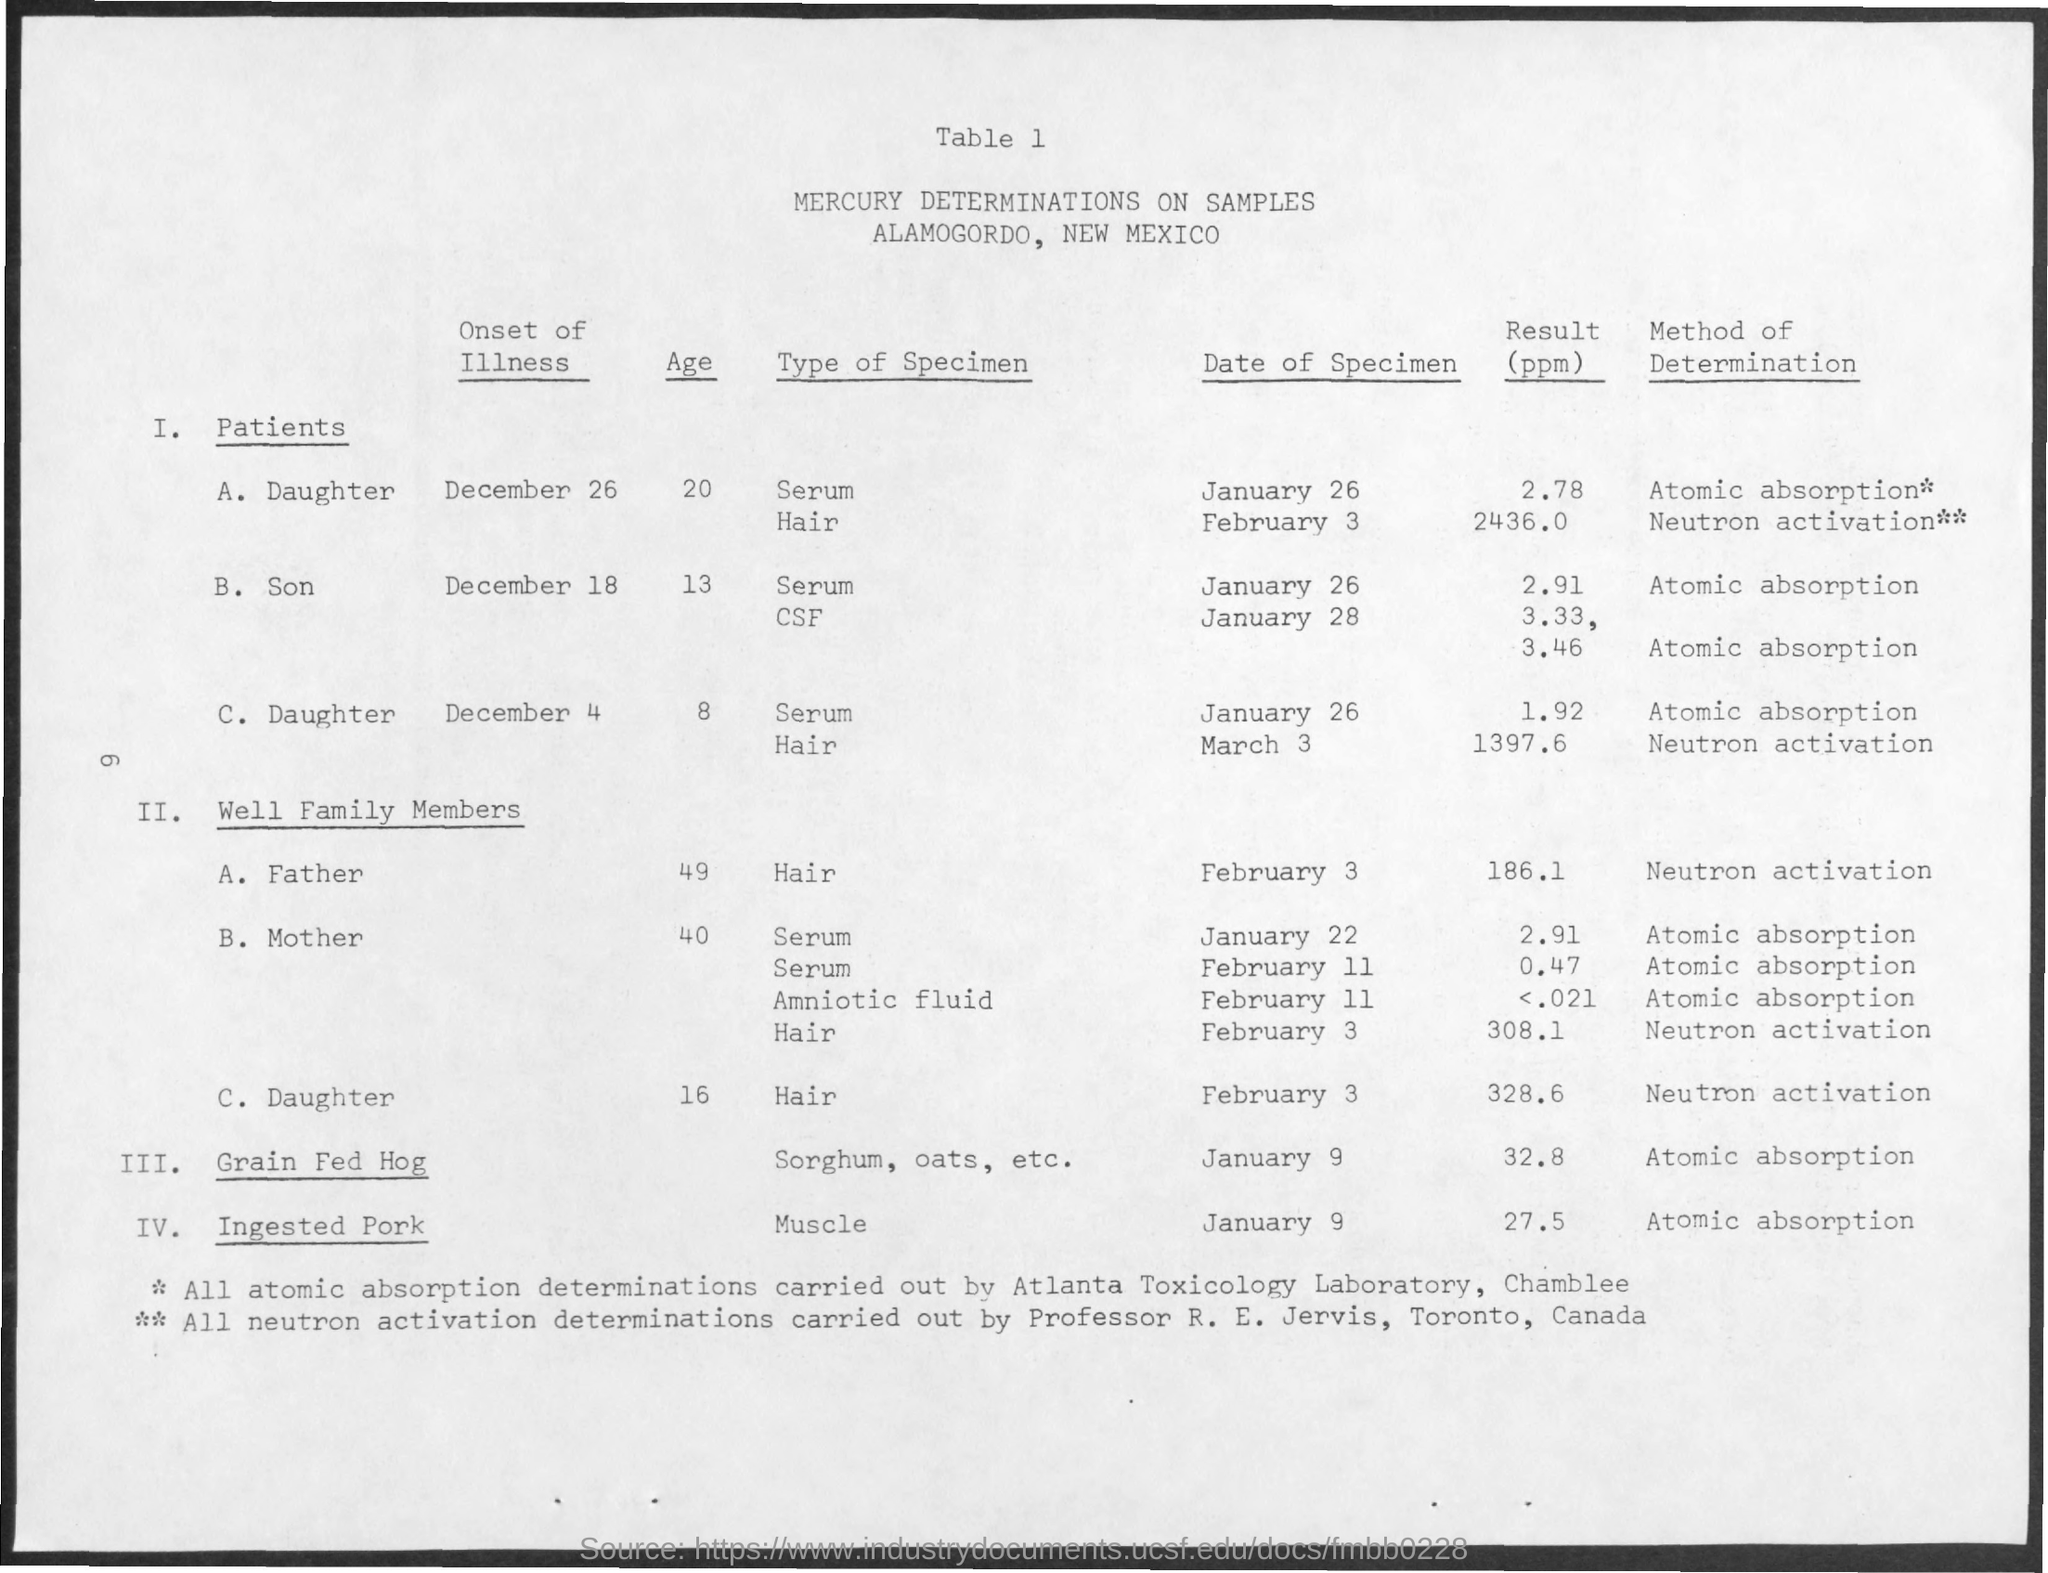What is the table heading?
Offer a very short reply. Mercury determinations on samples. All atomic absorption determination is carried out by which laboratory?
Keep it short and to the point. Atlanta Toxicology Laboratory. All neutron activation determinations are carried by whom?
Offer a terse response. Professor R. E. Jervis, Tornoto, Canada. What is the type of specimen collected from grain fed hog?
Keep it short and to the point. Sorghum, oats, etc. What is the result in case of Ingested pork?
Your response must be concise. 27.5. What is the method of determination for Grain fed Hog?
Ensure brevity in your answer.  Atomic absorption. What is the date of specimen for grain fed hog?
Provide a short and direct response. January 9. 